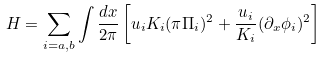Convert formula to latex. <formula><loc_0><loc_0><loc_500><loc_500>H = \sum _ { i = a , b } \int \frac { d x } { 2 \pi } \left [ u _ { i } K _ { i } ( \pi \Pi _ { i } ) ^ { 2 } + \frac { u _ { i } } { K _ { i } } ( \partial _ { x } \phi _ { i } ) ^ { 2 } \right ]</formula> 